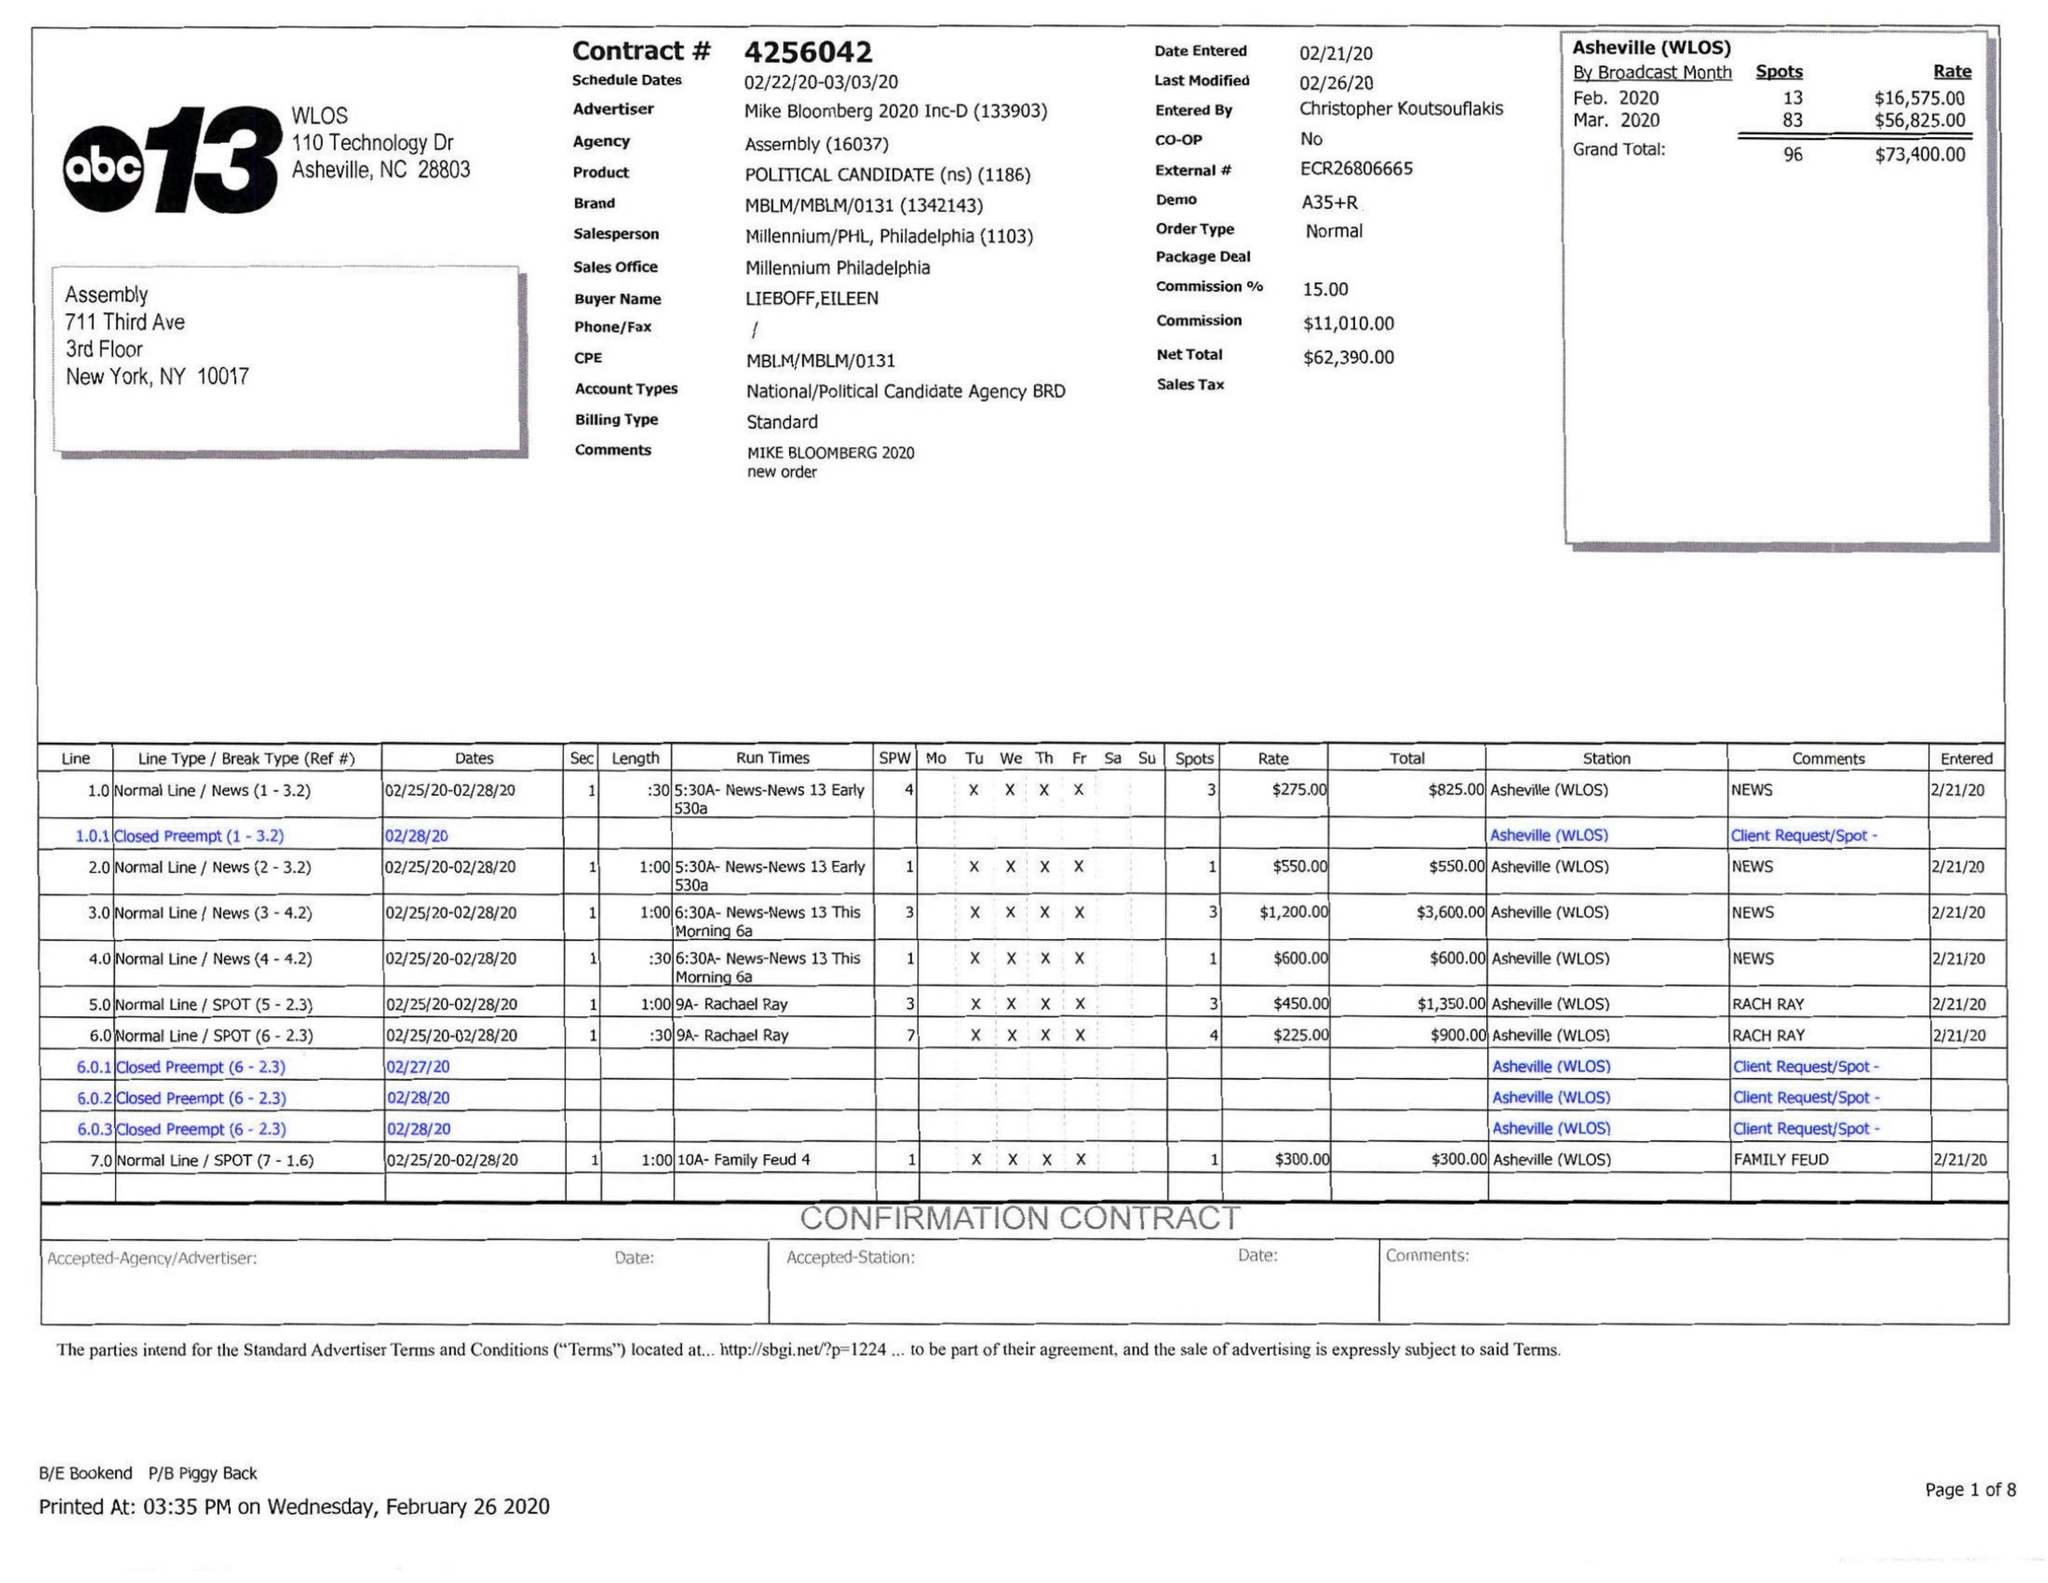What is the value for the contract_num?
Answer the question using a single word or phrase. 4256042 